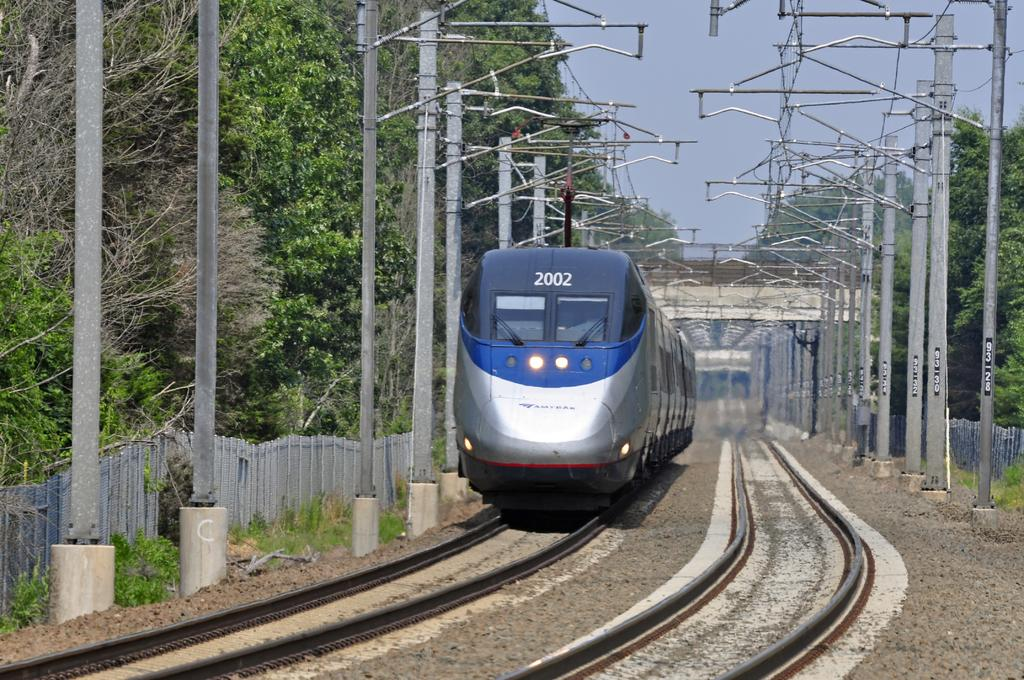What is the main subject of the image? The main subject of the image is a train on a track. What can be seen alongside the train in the image? There are poles with wires in the image. What type of vegetation is visible in the image? Grass and trees are present in the image. What is visible in the background of the image? There is a bridge and the sky visible in the background of the image. What type of bells can be heard ringing in the image? There are no bells present in the image, and therefore no sound can be heard. 